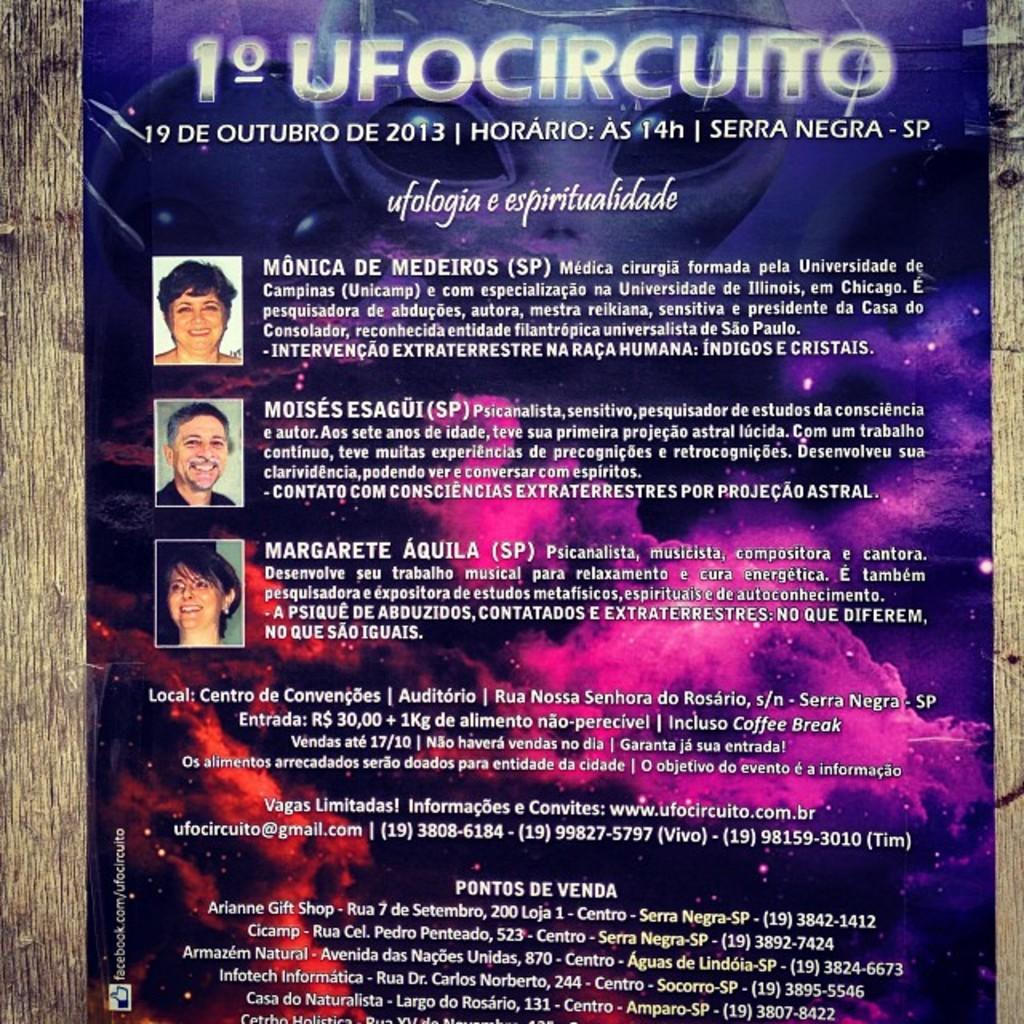Please provide a concise description of this image. In this image there is a poster on that poster, there are three pictures of persons and there is some text, on the left and right there is wood. 